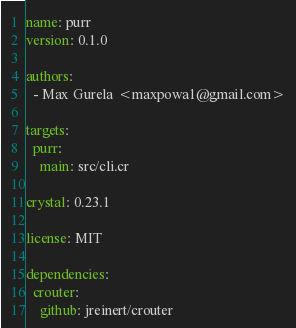<code> <loc_0><loc_0><loc_500><loc_500><_YAML_>name: purr
version: 0.1.0

authors:
  - Max Gurela <maxpowa1@gmail.com>

targets:
  purr:
    main: src/cli.cr

crystal: 0.23.1

license: MIT

dependencies:
  crouter:
    github: jreinert/crouter
</code> 